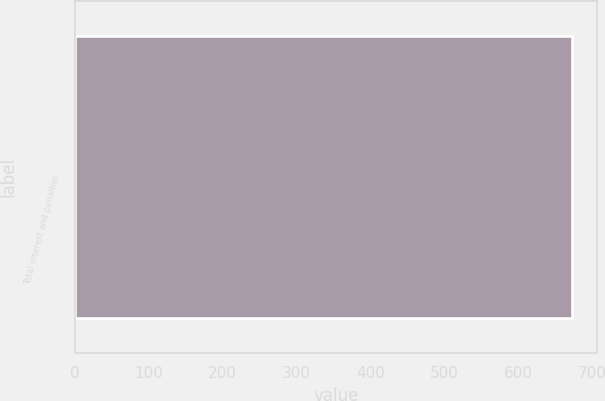Convert chart to OTSL. <chart><loc_0><loc_0><loc_500><loc_500><bar_chart><fcel>Total interest and penalties<nl><fcel>672.9<nl></chart> 